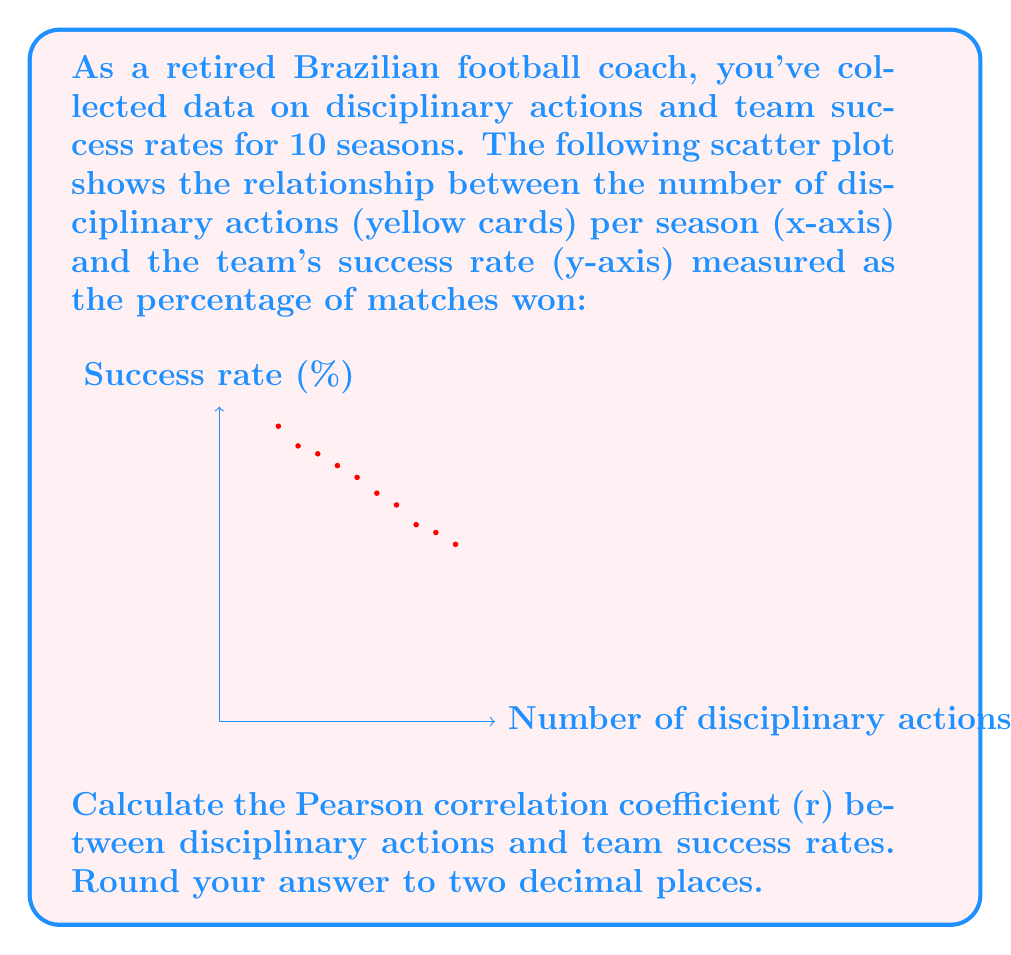Could you help me with this problem? To calculate the Pearson correlation coefficient (r), we'll use the formula:

$$ r = \frac{\sum_{i=1}^{n} (x_i - \bar{x})(y_i - \bar{y})}{\sqrt{\sum_{i=1}^{n} (x_i - \bar{x})^2 \sum_{i=1}^{n} (y_i - \bar{y})^2}} $$

Where:
$x_i$ = number of disciplinary actions
$y_i$ = success rate
$\bar{x}$ = mean of x
$\bar{y}$ = mean of y
n = number of data points (10 in this case)

Step 1: Calculate means
$\bar{x} = \frac{15 + 20 + 25 + 30 + 35 + 40 + 45 + 50 + 55 + 60}{10} = 37.5$
$\bar{y} = \frac{75 + 70 + 68 + 65 + 62 + 58 + 55 + 50 + 48 + 45}{10} = 59.6$

Step 2: Calculate $(x_i - \bar{x})$, $(y_i - \bar{y})$, $(x_i - \bar{x})^2$, $(y_i - \bar{y})^2$, and $(x_i - \bar{x})(y_i - \bar{y})$ for each data point.

Step 3: Sum up the values calculated in Step 2
$\sum (x_i - \bar{x})(y_i - \bar{y}) = 1837.5$
$\sum (x_i - \bar{x})^2 = 2812.5$
$\sum (y_i - \bar{y})^2 = 1144.4$

Step 4: Apply the formula
$$ r = \frac{1837.5}{\sqrt{2812.5 \times 1144.4}} = -0.9756 $$

Step 5: Round to two decimal places
r = -0.98
Answer: -0.98 